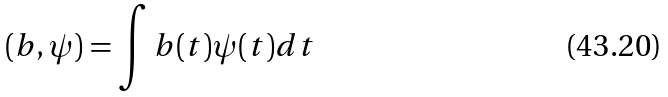Convert formula to latex. <formula><loc_0><loc_0><loc_500><loc_500>( b , \psi ) = \int b ( t ) \psi ( t ) d t</formula> 